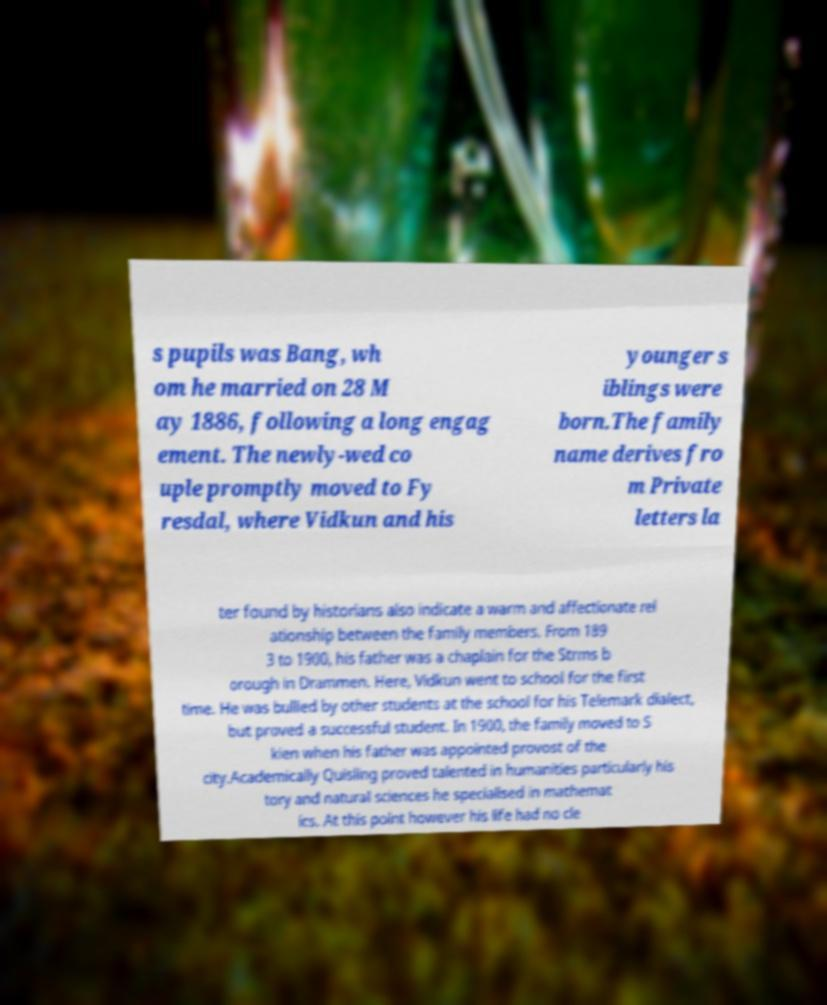Please read and relay the text visible in this image. What does it say? s pupils was Bang, wh om he married on 28 M ay 1886, following a long engag ement. The newly-wed co uple promptly moved to Fy resdal, where Vidkun and his younger s iblings were born.The family name derives fro m Private letters la ter found by historians also indicate a warm and affectionate rel ationship between the family members. From 189 3 to 1900, his father was a chaplain for the Strms b orough in Drammen. Here, Vidkun went to school for the first time. He was bullied by other students at the school for his Telemark dialect, but proved a successful student. In 1900, the family moved to S kien when his father was appointed provost of the city.Academically Quisling proved talented in humanities particularly his tory and natural sciences he specialised in mathemat ics. At this point however his life had no cle 